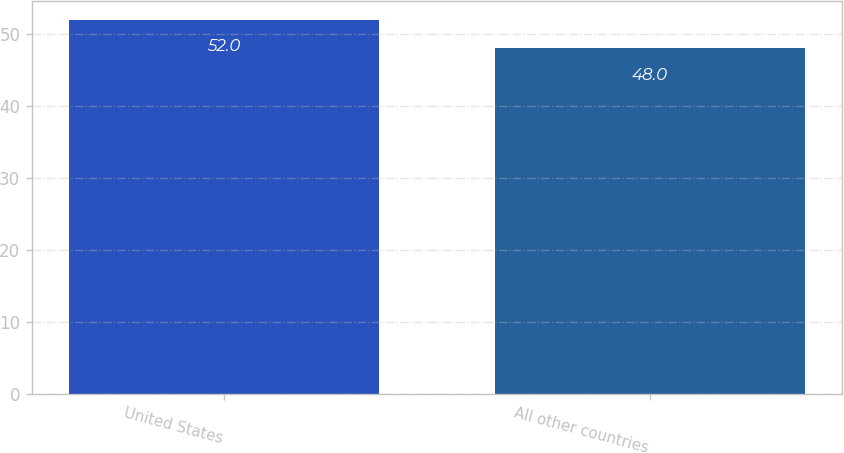Convert chart. <chart><loc_0><loc_0><loc_500><loc_500><bar_chart><fcel>United States<fcel>All other countries<nl><fcel>52<fcel>48<nl></chart> 